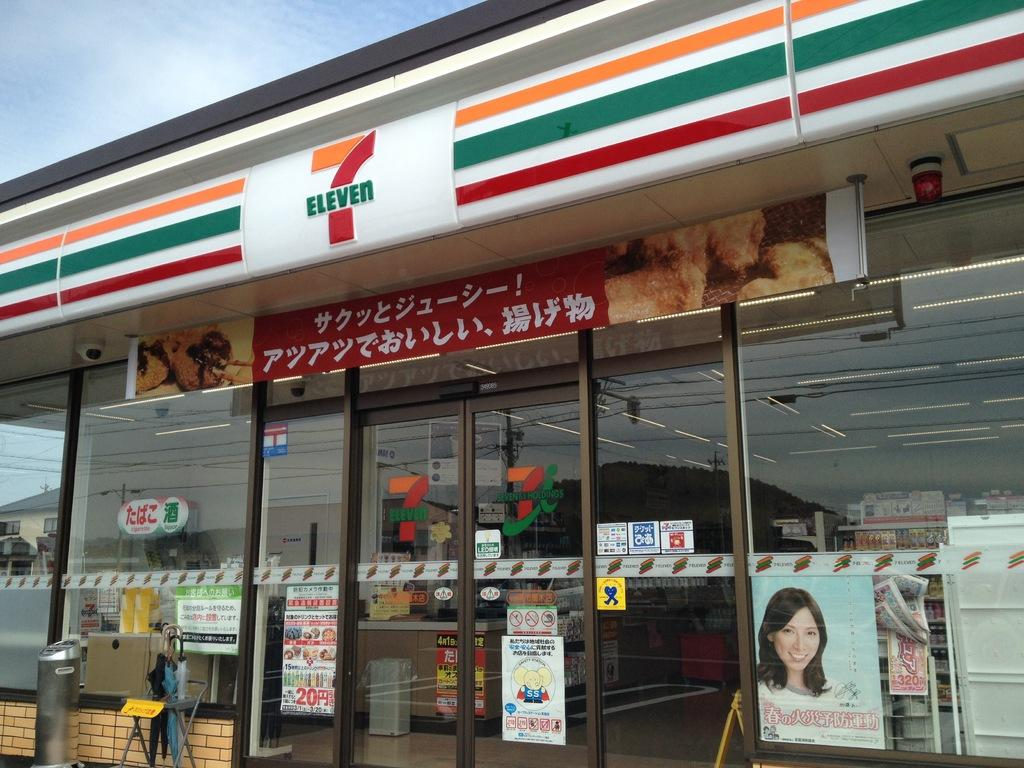<image>
Summarize the visual content of the image. the 7-11 has their advertisements written in a language that is not english 